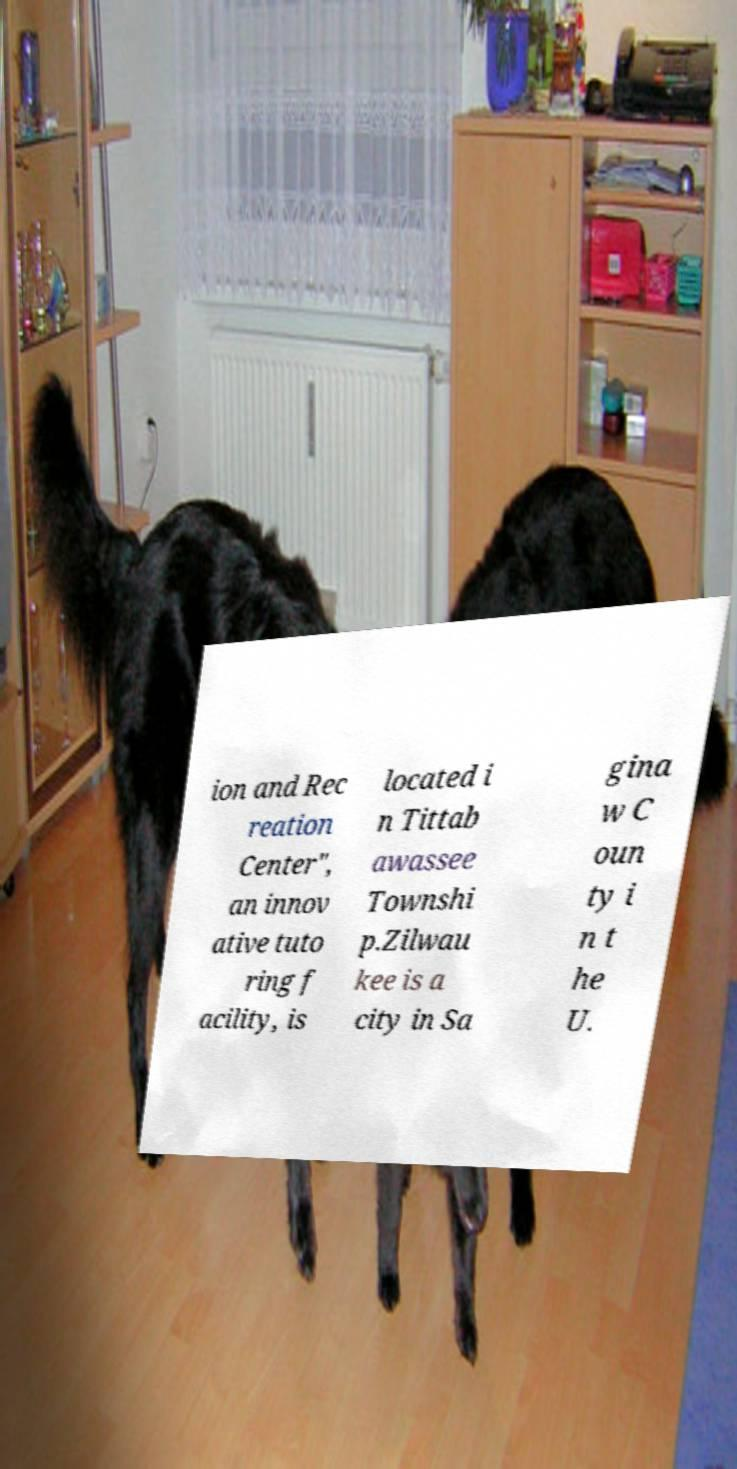Could you extract and type out the text from this image? ion and Rec reation Center", an innov ative tuto ring f acility, is located i n Tittab awassee Townshi p.Zilwau kee is a city in Sa gina w C oun ty i n t he U. 